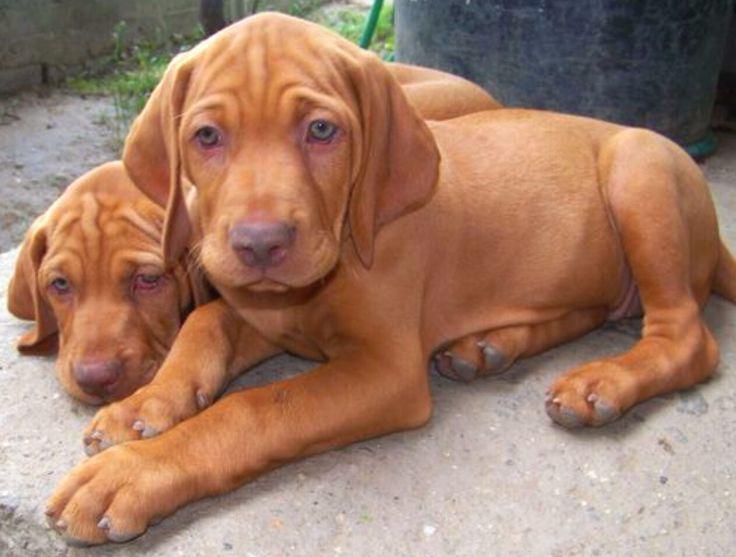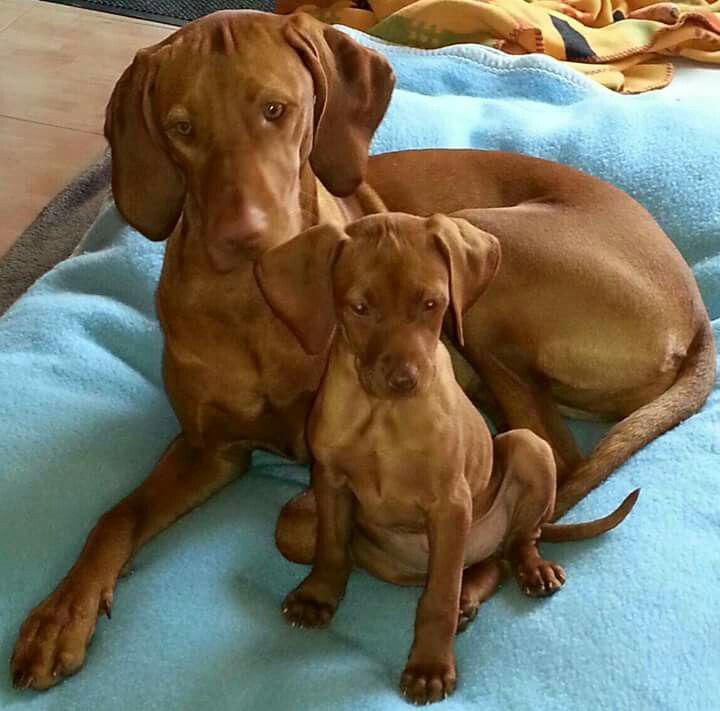The first image is the image on the left, the second image is the image on the right. Assess this claim about the two images: "There are more dogs in the image on the right.". Correct or not? Answer yes or no. No. The first image is the image on the left, the second image is the image on the right. Assess this claim about the two images: "There are three dog in a row with different color collars on.". Correct or not? Answer yes or no. No. 